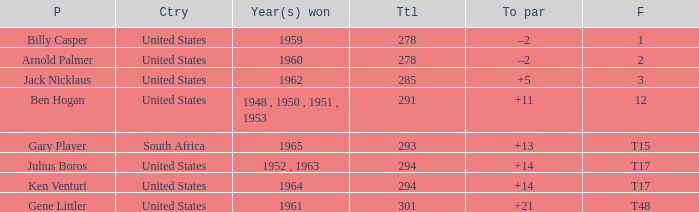In which year(s) was the victory when the total is under 285? 1959, 1960. 